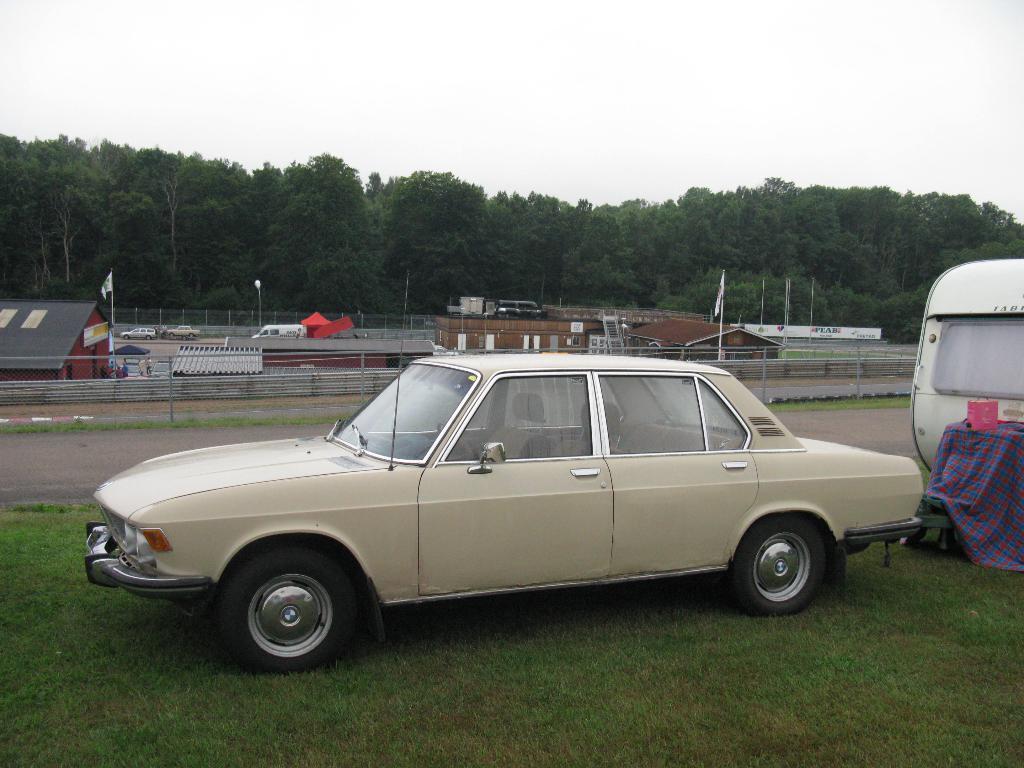How would you summarize this image in a sentence or two? This image is taken outdoors. At the top of the image there is the sky. In the background there are many trees and plants with green leaves. There are a few houses with walls, windows, doors and roofs. There are two flags. There are a few poles. A few vehicles are moving on the road. There is a tent. At the bottom of the image there is a ground with grass on it. In the middle of the image to vehicles are parked on the ground. 